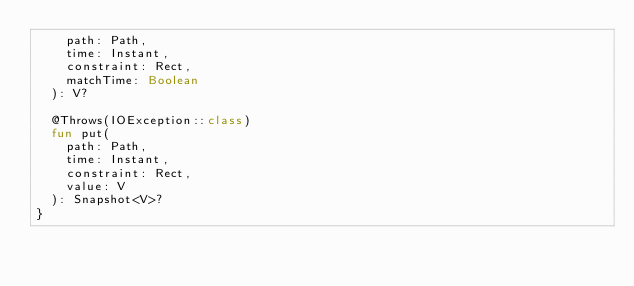Convert code to text. <code><loc_0><loc_0><loc_500><loc_500><_Kotlin_>    path: Path,
    time: Instant,
    constraint: Rect,
    matchTime: Boolean
  ): V?

  @Throws(IOException::class)
  fun put(
    path: Path,
    time: Instant,
    constraint: Rect,
    value: V
  ): Snapshot<V>?
}
</code> 